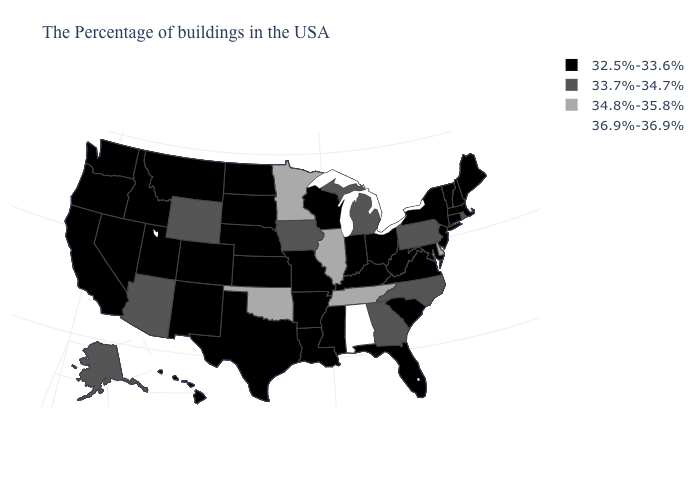Name the states that have a value in the range 32.5%-33.6%?
Short answer required. Maine, Massachusetts, New Hampshire, Vermont, Connecticut, New York, New Jersey, Maryland, Virginia, South Carolina, West Virginia, Ohio, Florida, Kentucky, Indiana, Wisconsin, Mississippi, Louisiana, Missouri, Arkansas, Kansas, Nebraska, Texas, South Dakota, North Dakota, Colorado, New Mexico, Utah, Montana, Idaho, Nevada, California, Washington, Oregon, Hawaii. What is the value of Rhode Island?
Write a very short answer. 33.7%-34.7%. Among the states that border Illinois , which have the highest value?
Write a very short answer. Iowa. Does Delaware have a higher value than Minnesota?
Be succinct. No. Does the map have missing data?
Concise answer only. No. What is the highest value in the USA?
Short answer required. 36.9%-36.9%. Name the states that have a value in the range 34.8%-35.8%?
Keep it brief. Delaware, Tennessee, Illinois, Minnesota, Oklahoma. Does Alabama have the highest value in the USA?
Be succinct. Yes. What is the lowest value in the West?
Concise answer only. 32.5%-33.6%. Among the states that border Tennessee , which have the lowest value?
Be succinct. Virginia, Kentucky, Mississippi, Missouri, Arkansas. What is the lowest value in states that border Maryland?
Short answer required. 32.5%-33.6%. What is the value of Illinois?
Give a very brief answer. 34.8%-35.8%. What is the value of Georgia?
Quick response, please. 33.7%-34.7%. Which states have the lowest value in the West?
Keep it brief. Colorado, New Mexico, Utah, Montana, Idaho, Nevada, California, Washington, Oregon, Hawaii. Which states have the highest value in the USA?
Answer briefly. Alabama. 